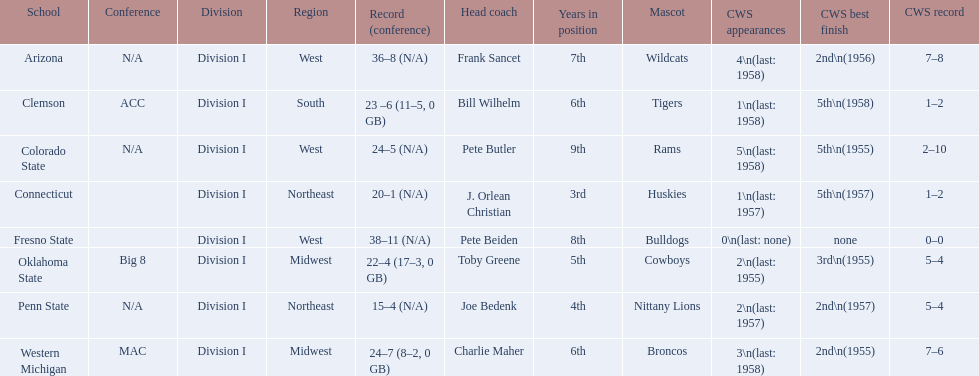What was the least amount of wins recorded by the losingest team? 15–4 (N/A). Which team held this record? Penn State. 